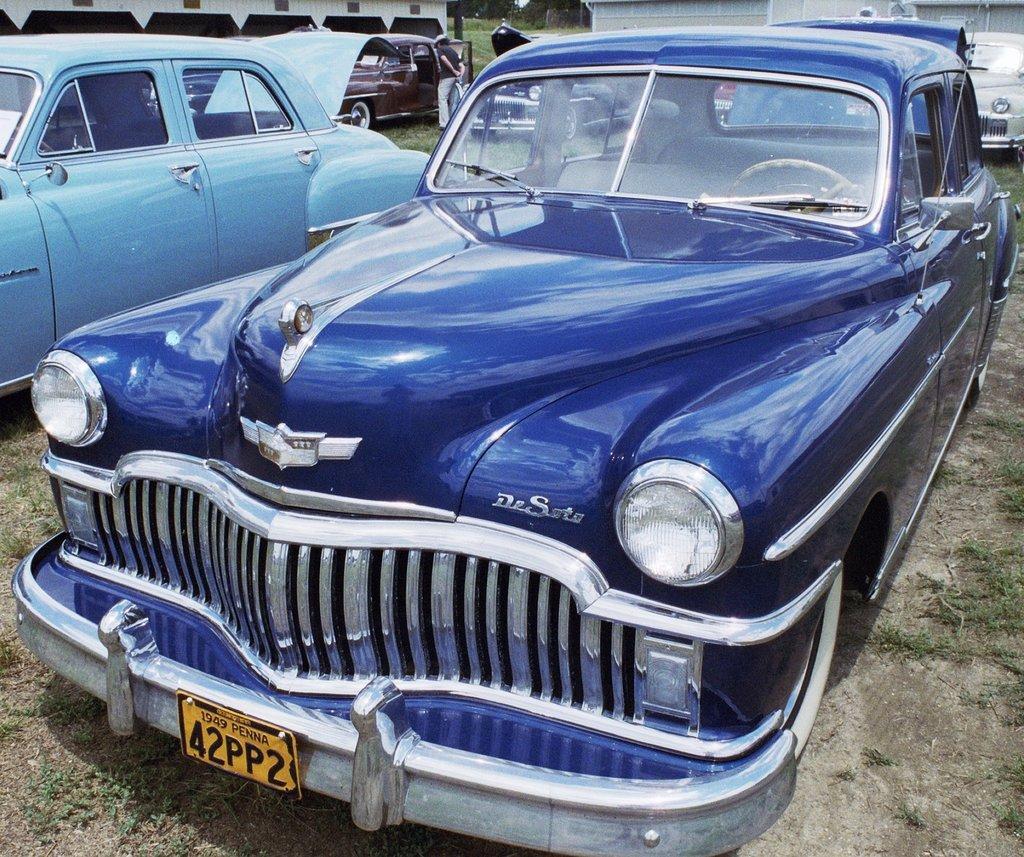Describe this image in one or two sentences. In this image we can see the cars parked on the land. We can also see the grass. In the background we can see a man standing. 